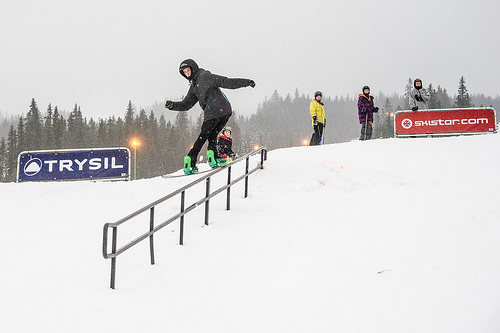What is covered in the snow? The hill is entirely covered in snow, making it perfect for winter sports and activities. 